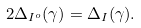Convert formula to latex. <formula><loc_0><loc_0><loc_500><loc_500>2 \Delta _ { I ^ { o } } ( \gamma ) = \Delta _ { I } ( \gamma ) .</formula> 